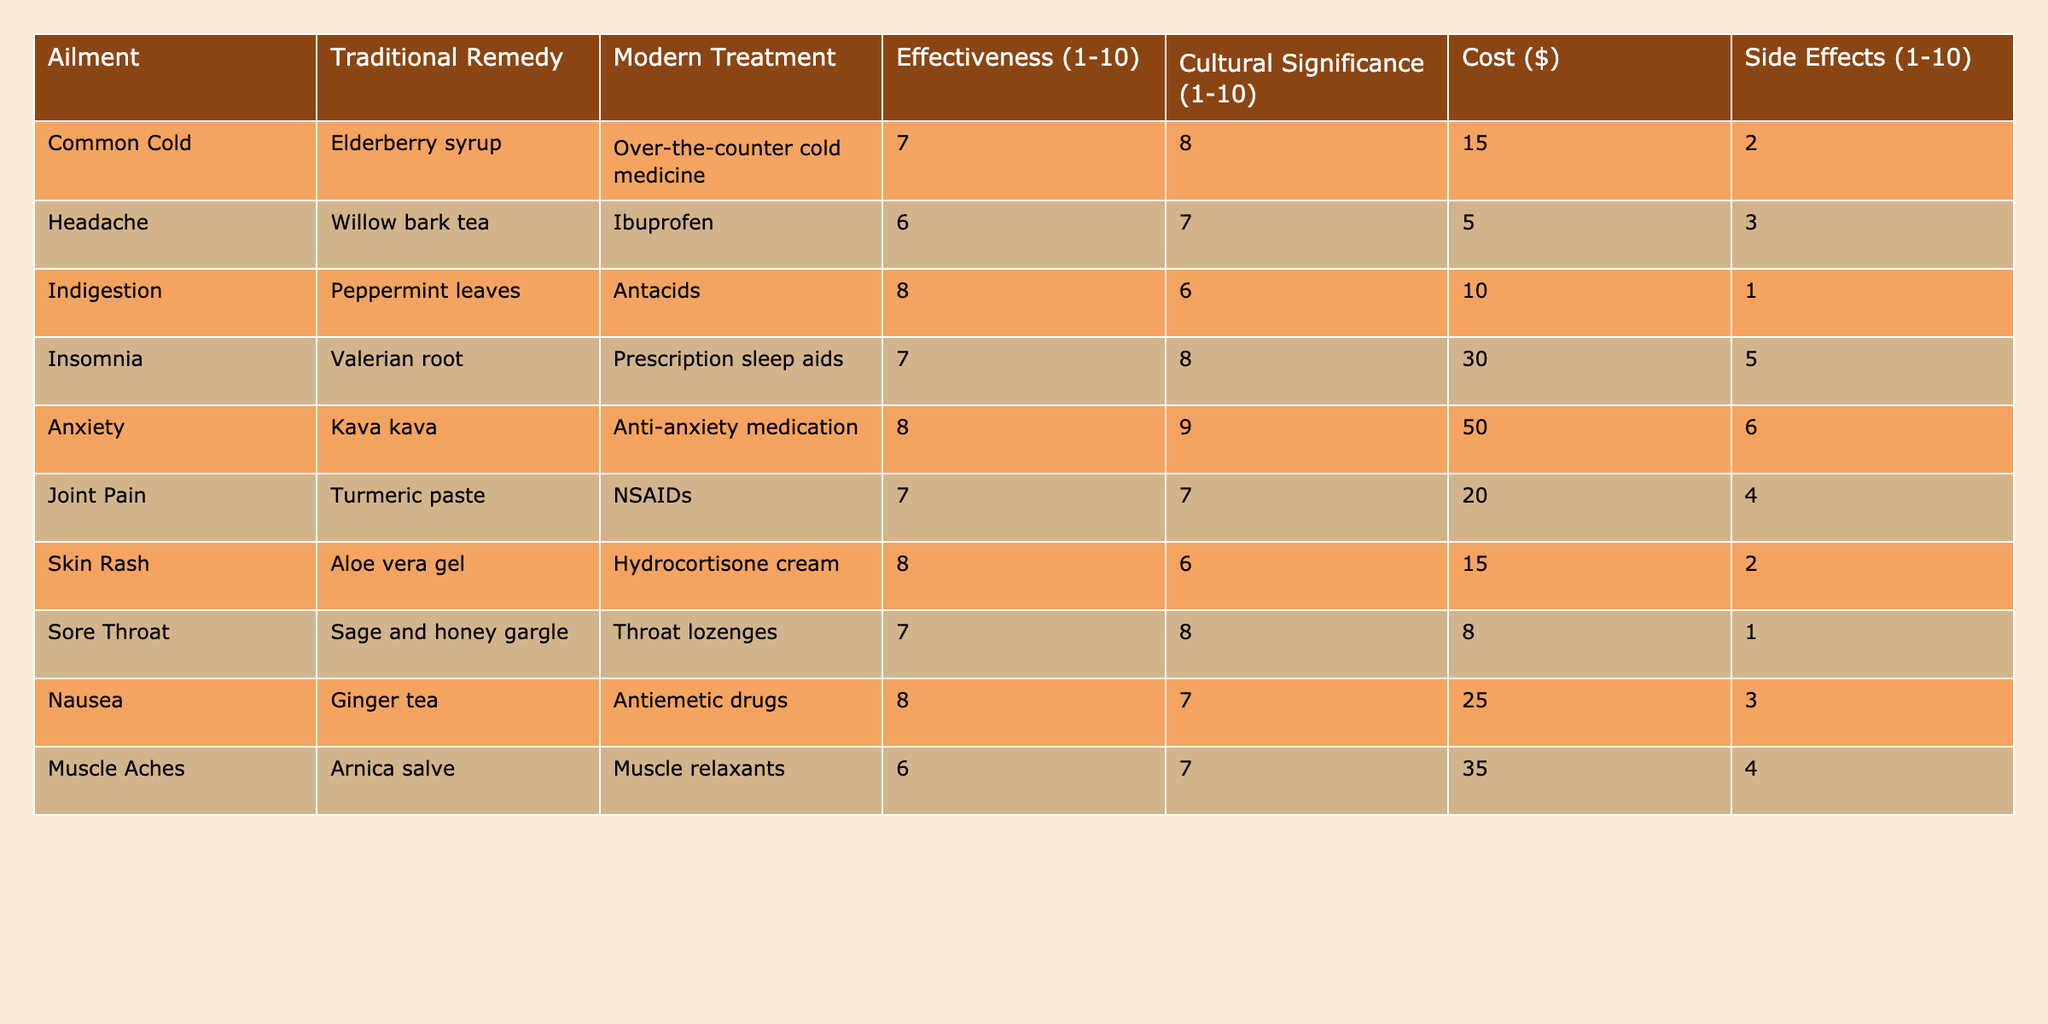What is the effectiveness rating for skin rash treatment? The effectiveness rating for skin rash treatment is the value listed under the "Effectiveness (1-10)" column for the "Skin Rash" row, which is 8.
Answer: 8 Which traditional remedy has the highest cost? By reviewing the "Cost ($)" column for all traditional remedies, the remedy with the highest cost is "Kava kava" for anxiety, which costs $50.
Answer: $50 What is the average effectiveness rating of modern treatments? To find the average, sum all the effectiveness ratings for modern treatments (7 + 6 + 8 + 7 + 8 + 7 + 8 + 7 + 8 + 6 = 78), and divide by the total number (10). Thus, the average is 78/10 = 7.8.
Answer: 7.8 Is the cultural significance score for anxiety treatment higher than the score for insomnia treatment? Comparing the "Cultural Significance (1-10)" values for anxiety (9) and insomnia (8), anxiety has a higher score.
Answer: Yes Which ailment has the lowest effectiveness rating for traditional remedies? The traditional remedy with the lowest effectiveness rating is "Willow bark tea" for headaches, which has a rating of 6.
Answer: 6 What is the total cost of all traditional remedies listed? The total cost is calculated by adding the values in the "Cost ($)" column (15 + 5 + 10 + 30 + 50 + 20 + 15 + 8 + 25 + 35 = 218).
Answer: $218 Which two ailments have the same effectiveness rating of 7 for traditional remedies? By checking the "Effectiveness (1-10)" for traditional remedies, both "Common Cold" and "Sore Throat" have a rating of 7.
Answer: Common Cold and Sore Throat Is there any ailment for which the traditional remedy is more effective than the modern treatment? By comparing the effectiveness ratings, traditional remedies for indigestion, anxiety, and skin rash all have higher effectiveness ratings (8) than their modern counterparts, which have ratings of 8, 7, and 8 respectively.
Answer: Yes What is the difference in effectiveness between modern and traditional treatments for joint pain? The effectiveness rating for traditional joint pain remedy (7) minus the modern treatment rating (6) gives a difference of 1.
Answer: 1 What is the total side effect score for all modern treatments combined? Add the side effects ratings for each modern treatment (2 + 3 + 1 + 5 + 6 + 4 + 1 + 3 + 4 + 3 = 32).
Answer: 32 